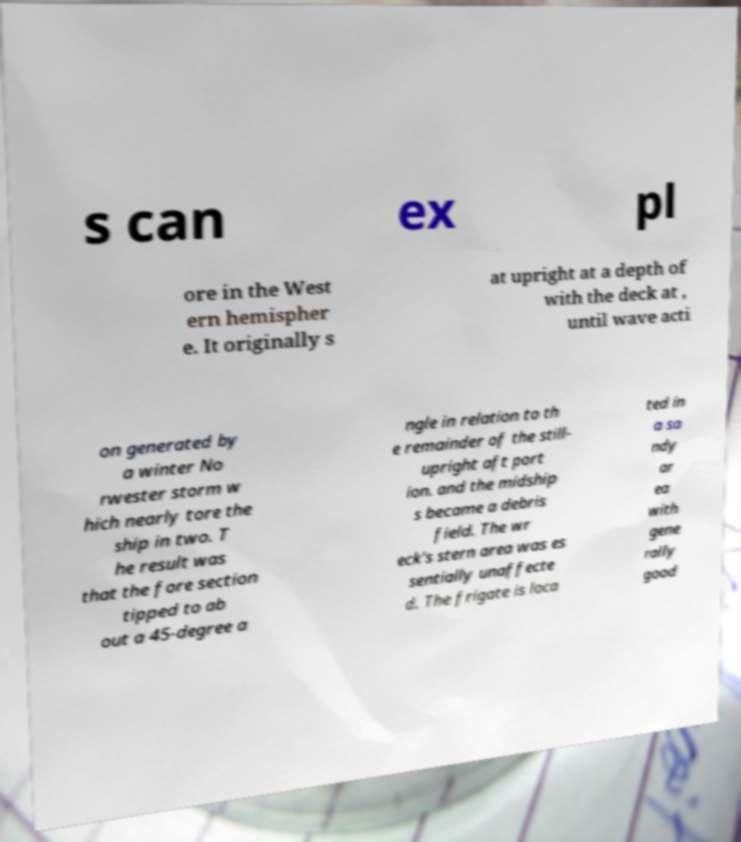Please read and relay the text visible in this image. What does it say? s can ex pl ore in the West ern hemispher e. It originally s at upright at a depth of with the deck at , until wave acti on generated by a winter No rwester storm w hich nearly tore the ship in two. T he result was that the fore section tipped to ab out a 45-degree a ngle in relation to th e remainder of the still- upright aft port ion. and the midship s became a debris field. The wr eck's stern area was es sentially unaffecte d. The frigate is loca ted in a sa ndy ar ea with gene rally good 